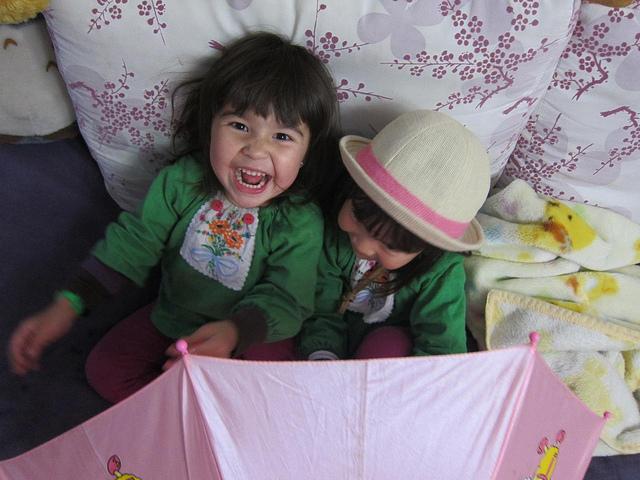Do the girls need their hair done?
Concise answer only. No. Are the children playing?
Short answer required. Yes. What color are they wearing?
Short answer required. Green. Why do these two children look so similar?
Give a very brief answer. Twins. 